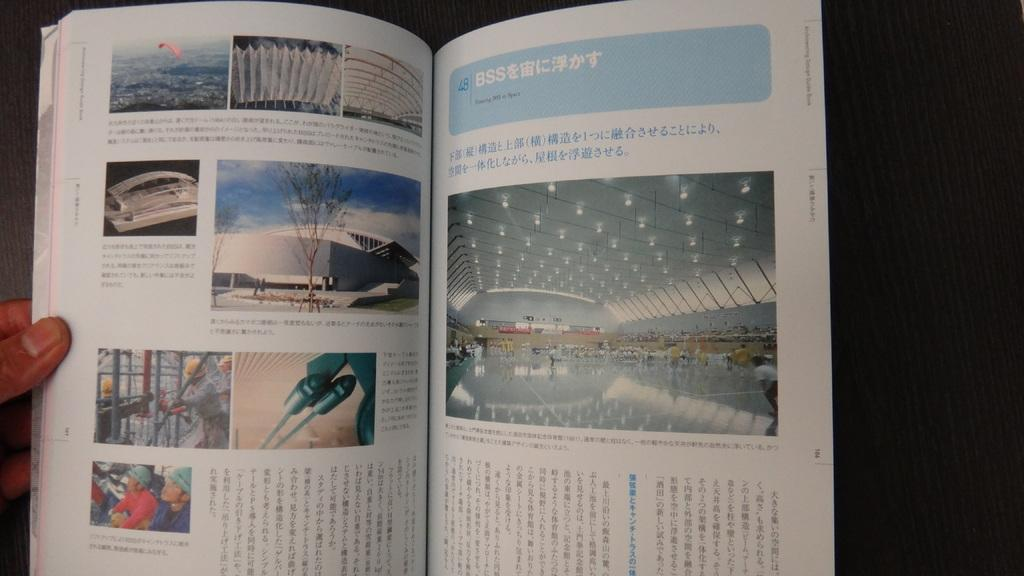<image>
Relay a brief, clear account of the picture shown. An open book with many pictures showcasing structure design and the title Floating BSS in Space on one of its pages. 